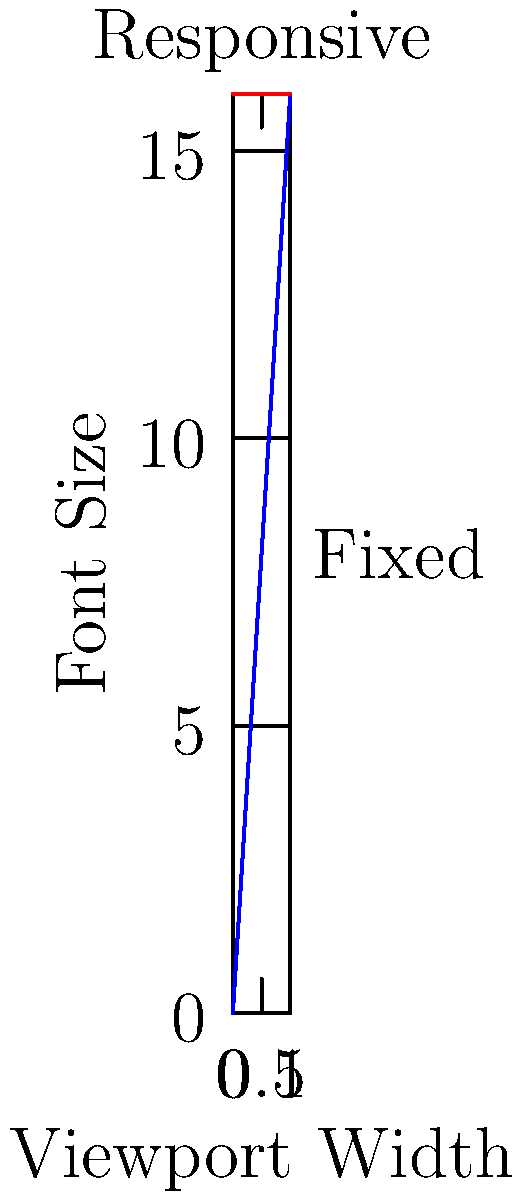In the graph above, which line represents a more responsive typography approach using viewport units, and why is it considered more adaptable for different screen sizes? To determine which line represents a more responsive typography approach:

1. Observe the two lines on the graph:
   - Blue line: increases linearly as viewport width increases
   - Red line: remains constant regardless of viewport width

2. Understand viewport units:
   - vw (viewport width) is relative to the width of the viewport
   - 1vw = 1% of viewport width

3. Interpret the lines:
   - Blue line ($16vw$): font size changes proportionally with viewport width
   - Red line ($16px$): font size remains fixed at 16 pixels

4. Consider responsiveness:
   - Responsive design adapts to different screen sizes
   - The blue line (16vw) scales with the viewport, making it more responsive
   - The red line (16px) doesn't change, making it less adaptable

5. Conclusion:
   The blue line represents a more responsive typography approach using viewport units (vw) because it adjusts the font size based on the viewport width, ensuring better readability and proportionality across different screen sizes.
Answer: The blue line (16vw), as it scales proportionally with viewport width. 